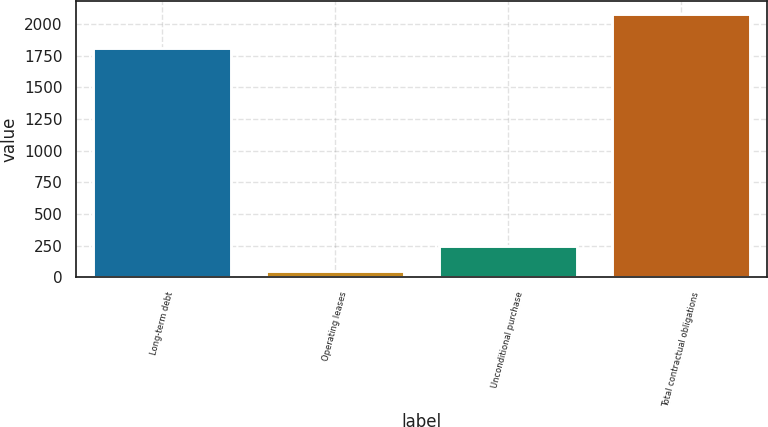Convert chart. <chart><loc_0><loc_0><loc_500><loc_500><bar_chart><fcel>Long-term debt<fcel>Operating leases<fcel>Unconditional purchase<fcel>Total contractual obligations<nl><fcel>1812<fcel>47<fcel>250<fcel>2077<nl></chart> 